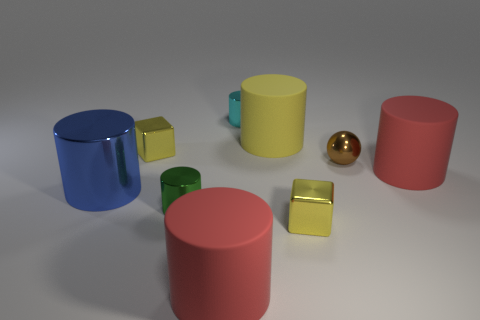Subtract all cylinders. How many objects are left? 3 Subtract all blue cylinders. How many cylinders are left? 5 Add 7 green shiny things. How many green shiny things are left? 8 Add 6 brown shiny objects. How many brown shiny objects exist? 7 Subtract all cyan metallic cylinders. How many cylinders are left? 5 Subtract 0 gray cylinders. How many objects are left? 9 Subtract 5 cylinders. How many cylinders are left? 1 Subtract all green spheres. Subtract all blue cubes. How many spheres are left? 1 Subtract all green balls. How many blue cubes are left? 0 Subtract all big purple metallic balls. Subtract all yellow rubber cylinders. How many objects are left? 8 